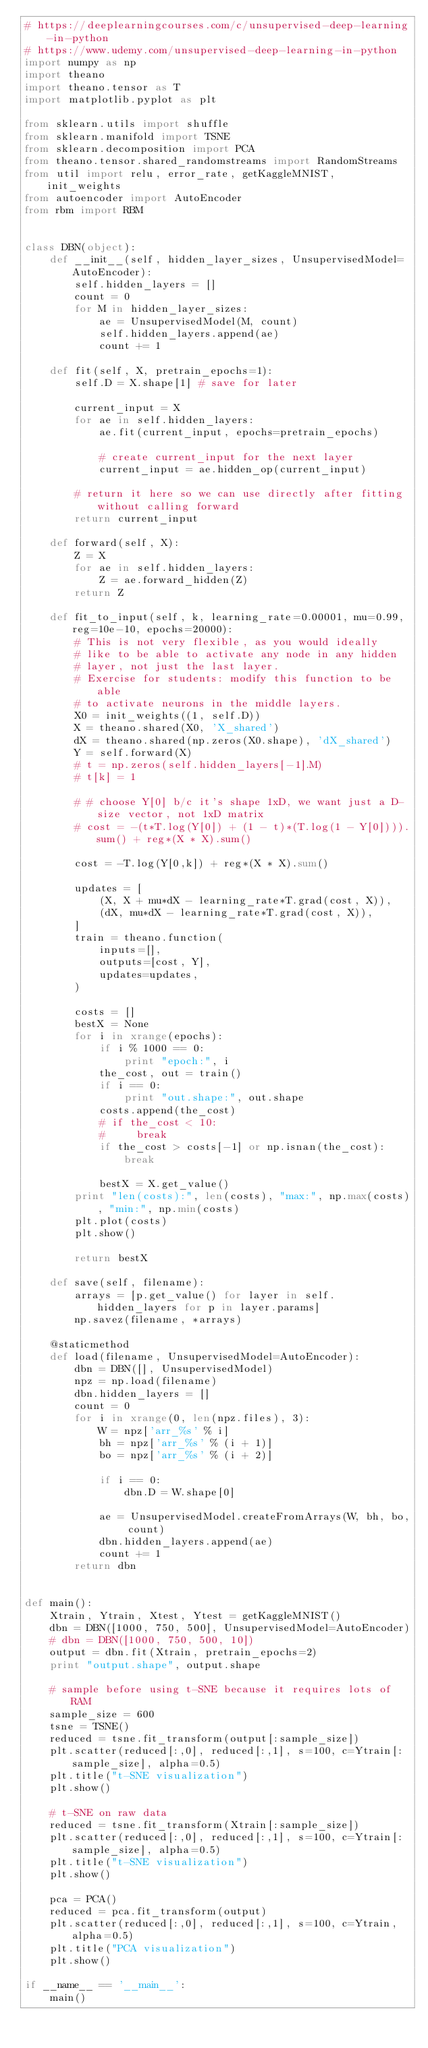<code> <loc_0><loc_0><loc_500><loc_500><_Python_># https://deeplearningcourses.com/c/unsupervised-deep-learning-in-python
# https://www.udemy.com/unsupervised-deep-learning-in-python
import numpy as np
import theano
import theano.tensor as T
import matplotlib.pyplot as plt

from sklearn.utils import shuffle
from sklearn.manifold import TSNE
from sklearn.decomposition import PCA
from theano.tensor.shared_randomstreams import RandomStreams
from util import relu, error_rate, getKaggleMNIST, init_weights
from autoencoder import AutoEncoder
from rbm import RBM


class DBN(object):
    def __init__(self, hidden_layer_sizes, UnsupervisedModel=AutoEncoder):
        self.hidden_layers = []
        count = 0
        for M in hidden_layer_sizes:
            ae = UnsupervisedModel(M, count)
            self.hidden_layers.append(ae)
            count += 1

    def fit(self, X, pretrain_epochs=1):
        self.D = X.shape[1] # save for later

        current_input = X
        for ae in self.hidden_layers:
            ae.fit(current_input, epochs=pretrain_epochs)

            # create current_input for the next layer
            current_input = ae.hidden_op(current_input)

        # return it here so we can use directly after fitting without calling forward
        return current_input

    def forward(self, X):
        Z = X
        for ae in self.hidden_layers:
            Z = ae.forward_hidden(Z)
        return Z

    def fit_to_input(self, k, learning_rate=0.00001, mu=0.99, reg=10e-10, epochs=20000):
        # This is not very flexible, as you would ideally
        # like to be able to activate any node in any hidden
        # layer, not just the last layer.
        # Exercise for students: modify this function to be able
        # to activate neurons in the middle layers.
        X0 = init_weights((1, self.D))
        X = theano.shared(X0, 'X_shared')
        dX = theano.shared(np.zeros(X0.shape), 'dX_shared')
        Y = self.forward(X)
        # t = np.zeros(self.hidden_layers[-1].M)
        # t[k] = 1

        # # choose Y[0] b/c it's shape 1xD, we want just a D-size vector, not 1xD matrix
        # cost = -(t*T.log(Y[0]) + (1 - t)*(T.log(1 - Y[0]))).sum() + reg*(X * X).sum()

        cost = -T.log(Y[0,k]) + reg*(X * X).sum()

        updates = [
            (X, X + mu*dX - learning_rate*T.grad(cost, X)),
            (dX, mu*dX - learning_rate*T.grad(cost, X)),
        ]
        train = theano.function(
            inputs=[],
            outputs=[cost, Y],
            updates=updates,
        )

        costs = []
        bestX = None
        for i in xrange(epochs):
            if i % 1000 == 0:
                print "epoch:", i
            the_cost, out = train()
            if i == 0:
                print "out.shape:", out.shape
            costs.append(the_cost)
            # if the_cost < 10:
            #     break
            if the_cost > costs[-1] or np.isnan(the_cost):
                break

            bestX = X.get_value()
        print "len(costs):", len(costs), "max:", np.max(costs), "min:", np.min(costs)
        plt.plot(costs)
        plt.show()

        return bestX

    def save(self, filename):
        arrays = [p.get_value() for layer in self.hidden_layers for p in layer.params]
        np.savez(filename, *arrays)

    @staticmethod
    def load(filename, UnsupervisedModel=AutoEncoder):
        dbn = DBN([], UnsupervisedModel)
        npz = np.load(filename)
        dbn.hidden_layers = []
        count = 0
        for i in xrange(0, len(npz.files), 3):
            W = npz['arr_%s' % i]
            bh = npz['arr_%s' % (i + 1)]
            bo = npz['arr_%s' % (i + 2)]

            if i == 0:
                dbn.D = W.shape[0]

            ae = UnsupervisedModel.createFromArrays(W, bh, bo, count)
            dbn.hidden_layers.append(ae)
            count += 1
        return dbn


def main():
    Xtrain, Ytrain, Xtest, Ytest = getKaggleMNIST()
    dbn = DBN([1000, 750, 500], UnsupervisedModel=AutoEncoder)
    # dbn = DBN([1000, 750, 500, 10])
    output = dbn.fit(Xtrain, pretrain_epochs=2)
    print "output.shape", output.shape

    # sample before using t-SNE because it requires lots of RAM
    sample_size = 600
    tsne = TSNE()
    reduced = tsne.fit_transform(output[:sample_size])
    plt.scatter(reduced[:,0], reduced[:,1], s=100, c=Ytrain[:sample_size], alpha=0.5)
    plt.title("t-SNE visualization")
    plt.show()

    # t-SNE on raw data
    reduced = tsne.fit_transform(Xtrain[:sample_size])
    plt.scatter(reduced[:,0], reduced[:,1], s=100, c=Ytrain[:sample_size], alpha=0.5)
    plt.title("t-SNE visualization")
    plt.show()

    pca = PCA()
    reduced = pca.fit_transform(output)
    plt.scatter(reduced[:,0], reduced[:,1], s=100, c=Ytrain, alpha=0.5)
    plt.title("PCA visualization")
    plt.show()

if __name__ == '__main__':
    main()</code> 